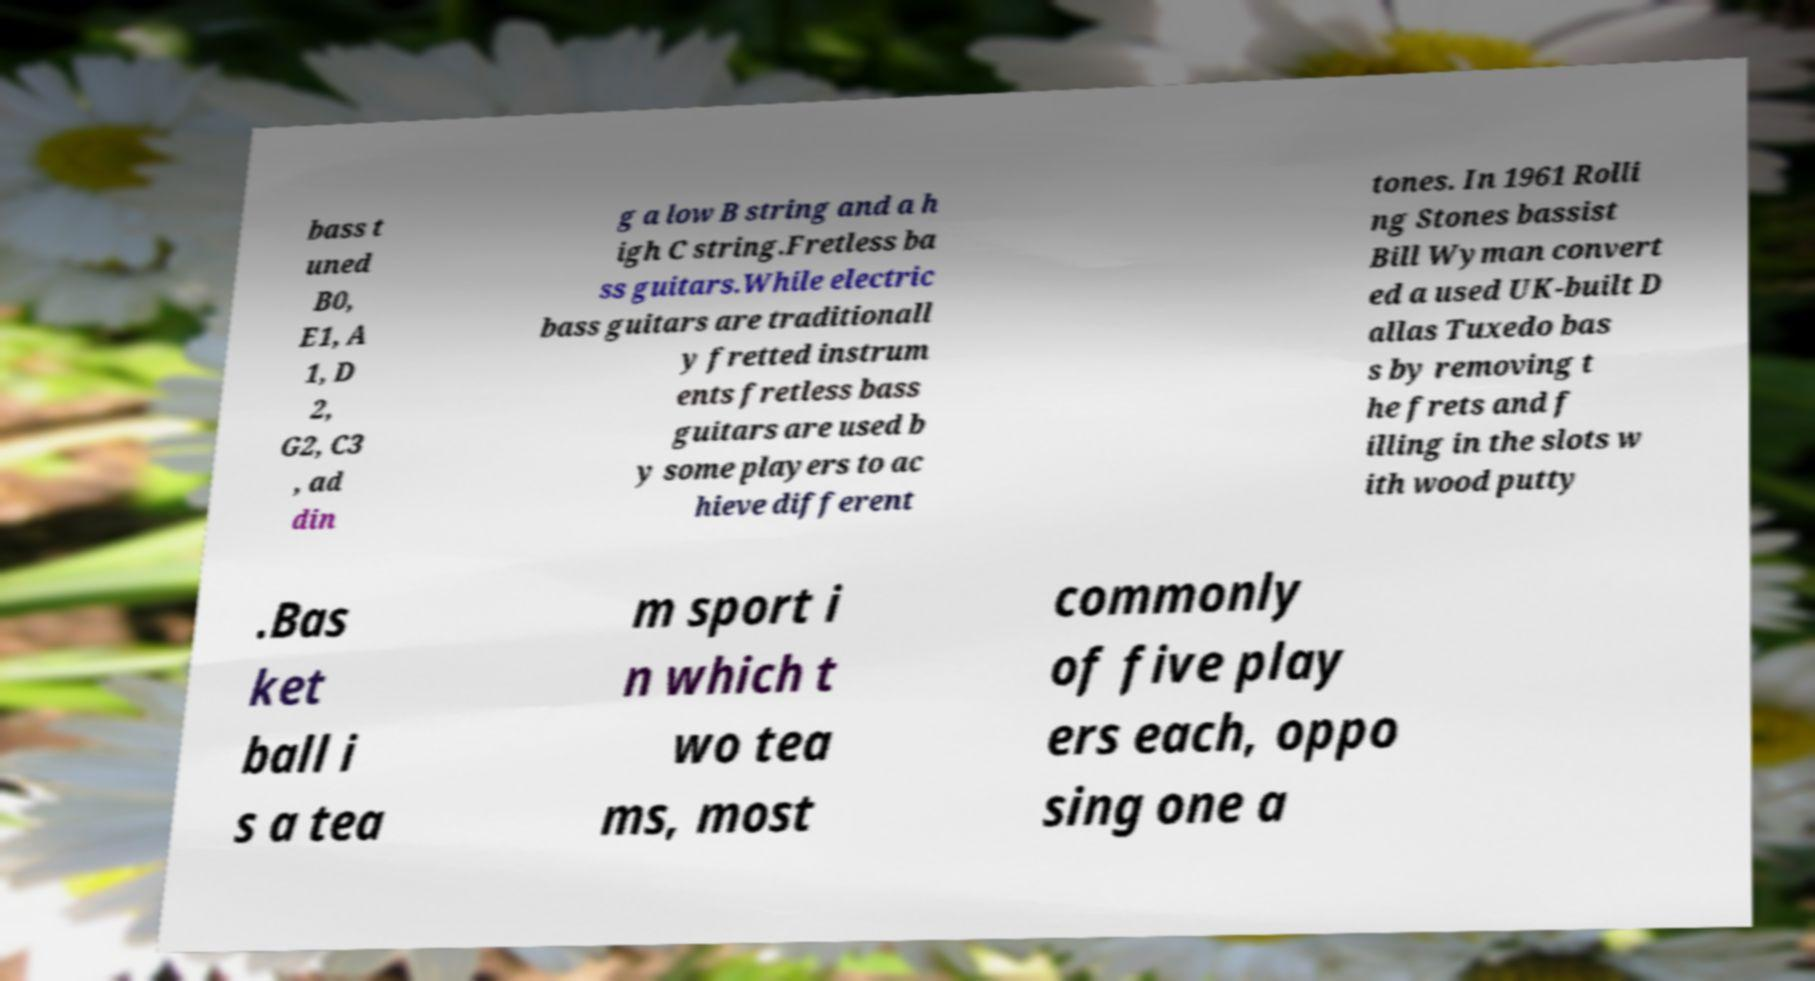For documentation purposes, I need the text within this image transcribed. Could you provide that? bass t uned B0, E1, A 1, D 2, G2, C3 , ad din g a low B string and a h igh C string.Fretless ba ss guitars.While electric bass guitars are traditionall y fretted instrum ents fretless bass guitars are used b y some players to ac hieve different tones. In 1961 Rolli ng Stones bassist Bill Wyman convert ed a used UK-built D allas Tuxedo bas s by removing t he frets and f illing in the slots w ith wood putty .Bas ket ball i s a tea m sport i n which t wo tea ms, most commonly of five play ers each, oppo sing one a 